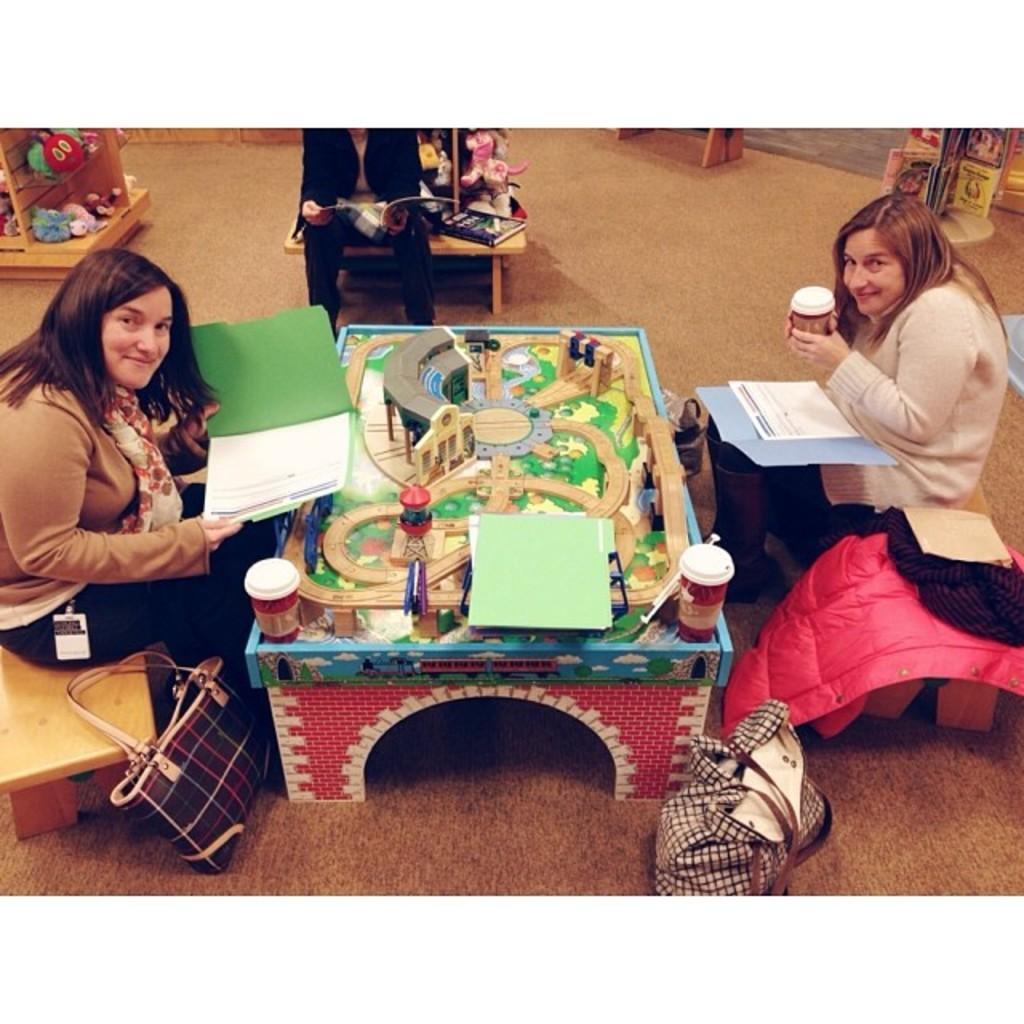In one or two sentences, can you explain what this image depicts? In this image there are three person sitting on the bench and there is a miniature and a cup. On the floor there is a bag. 